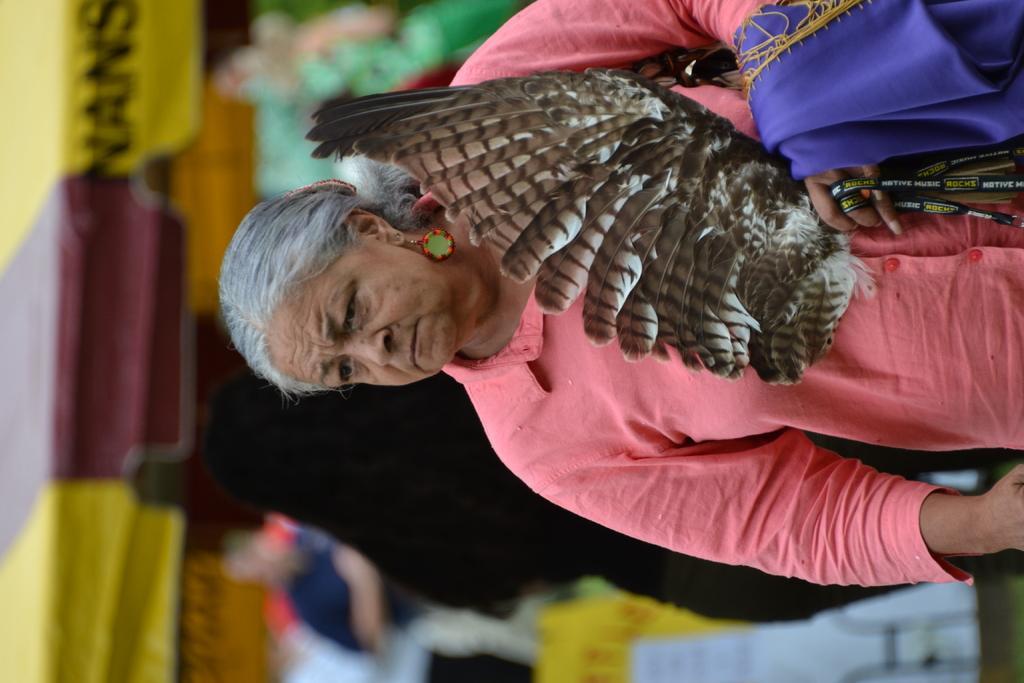In one or two sentences, can you explain what this image depicts? There is one women standing and holding some objects as we can see in the middle of this image. 